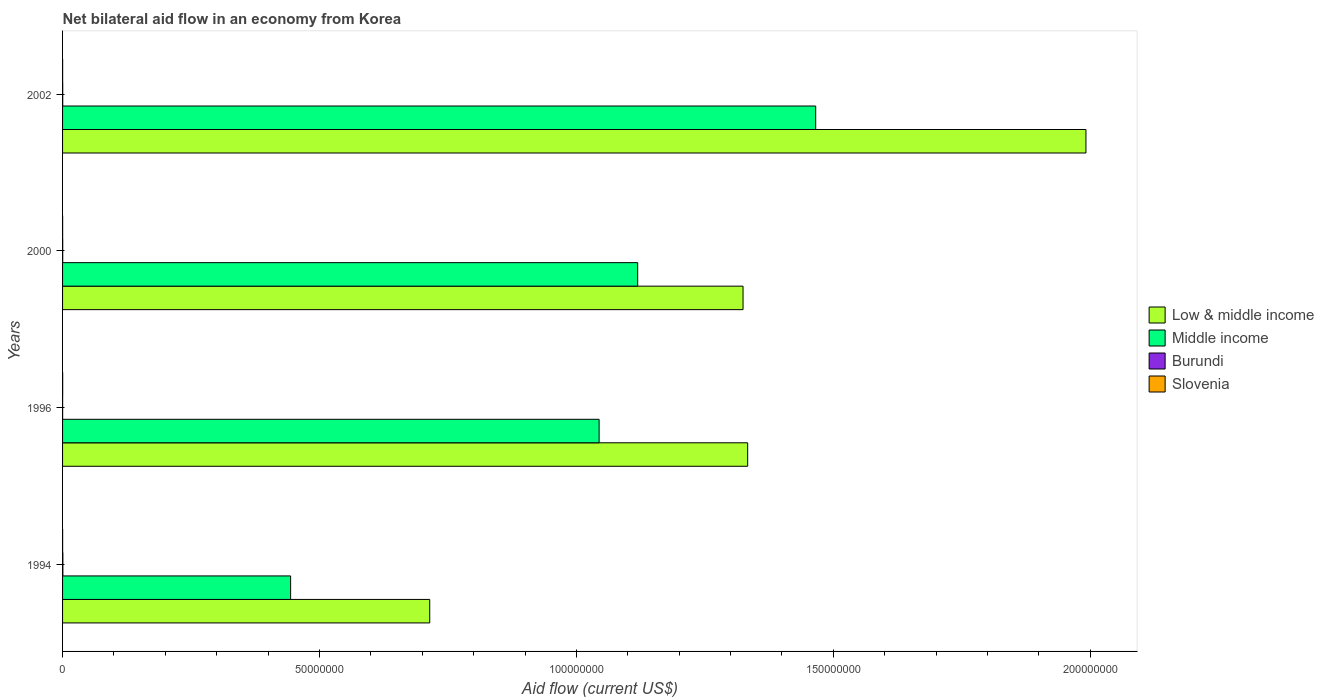How many different coloured bars are there?
Your answer should be very brief. 4. How many bars are there on the 1st tick from the bottom?
Provide a short and direct response. 4. What is the net bilateral aid flow in Low & middle income in 2000?
Offer a terse response. 1.32e+08. Across all years, what is the maximum net bilateral aid flow in Low & middle income?
Keep it short and to the point. 1.99e+08. Across all years, what is the minimum net bilateral aid flow in Burundi?
Offer a terse response. 10000. What is the difference between the net bilateral aid flow in Middle income in 2000 and that in 2002?
Offer a terse response. -3.46e+07. What is the difference between the net bilateral aid flow in Low & middle income in 1994 and the net bilateral aid flow in Burundi in 2002?
Your response must be concise. 7.14e+07. What is the average net bilateral aid flow in Low & middle income per year?
Keep it short and to the point. 1.34e+08. In the year 2002, what is the difference between the net bilateral aid flow in Low & middle income and net bilateral aid flow in Burundi?
Keep it short and to the point. 1.99e+08. Is the net bilateral aid flow in Low & middle income in 1996 less than that in 2000?
Make the answer very short. No. Is the difference between the net bilateral aid flow in Low & middle income in 1994 and 2002 greater than the difference between the net bilateral aid flow in Burundi in 1994 and 2002?
Make the answer very short. No. What is the difference between the highest and the second highest net bilateral aid flow in Middle income?
Provide a short and direct response. 3.46e+07. What is the difference between the highest and the lowest net bilateral aid flow in Low & middle income?
Your answer should be very brief. 1.28e+08. Is the sum of the net bilateral aid flow in Burundi in 1994 and 1996 greater than the maximum net bilateral aid flow in Low & middle income across all years?
Make the answer very short. No. What does the 2nd bar from the top in 1994 represents?
Keep it short and to the point. Burundi. How many years are there in the graph?
Your response must be concise. 4. What is the difference between two consecutive major ticks on the X-axis?
Ensure brevity in your answer.  5.00e+07. Are the values on the major ticks of X-axis written in scientific E-notation?
Offer a terse response. No. Does the graph contain grids?
Provide a short and direct response. No. How are the legend labels stacked?
Your answer should be very brief. Vertical. What is the title of the graph?
Offer a very short reply. Net bilateral aid flow in an economy from Korea. What is the Aid flow (current US$) in Low & middle income in 1994?
Ensure brevity in your answer.  7.14e+07. What is the Aid flow (current US$) in Middle income in 1994?
Provide a succinct answer. 4.44e+07. What is the Aid flow (current US$) in Burundi in 1994?
Ensure brevity in your answer.  6.00e+04. What is the Aid flow (current US$) in Slovenia in 1994?
Ensure brevity in your answer.  10000. What is the Aid flow (current US$) of Low & middle income in 1996?
Offer a very short reply. 1.33e+08. What is the Aid flow (current US$) of Middle income in 1996?
Offer a very short reply. 1.04e+08. What is the Aid flow (current US$) in Burundi in 1996?
Offer a very short reply. 10000. What is the Aid flow (current US$) of Slovenia in 1996?
Give a very brief answer. 2.00e+04. What is the Aid flow (current US$) in Low & middle income in 2000?
Make the answer very short. 1.32e+08. What is the Aid flow (current US$) of Middle income in 2000?
Provide a succinct answer. 1.12e+08. What is the Aid flow (current US$) in Burundi in 2000?
Your response must be concise. 3.00e+04. What is the Aid flow (current US$) in Slovenia in 2000?
Offer a terse response. 10000. What is the Aid flow (current US$) of Low & middle income in 2002?
Your answer should be compact. 1.99e+08. What is the Aid flow (current US$) of Middle income in 2002?
Provide a succinct answer. 1.47e+08. What is the Aid flow (current US$) of Burundi in 2002?
Make the answer very short. 3.00e+04. What is the Aid flow (current US$) of Slovenia in 2002?
Make the answer very short. 10000. Across all years, what is the maximum Aid flow (current US$) in Low & middle income?
Offer a very short reply. 1.99e+08. Across all years, what is the maximum Aid flow (current US$) in Middle income?
Offer a terse response. 1.47e+08. Across all years, what is the maximum Aid flow (current US$) of Burundi?
Offer a very short reply. 6.00e+04. Across all years, what is the maximum Aid flow (current US$) of Slovenia?
Make the answer very short. 2.00e+04. Across all years, what is the minimum Aid flow (current US$) of Low & middle income?
Your answer should be very brief. 7.14e+07. Across all years, what is the minimum Aid flow (current US$) in Middle income?
Offer a terse response. 4.44e+07. Across all years, what is the minimum Aid flow (current US$) in Burundi?
Your response must be concise. 10000. Across all years, what is the minimum Aid flow (current US$) in Slovenia?
Offer a terse response. 10000. What is the total Aid flow (current US$) in Low & middle income in the graph?
Give a very brief answer. 5.36e+08. What is the total Aid flow (current US$) of Middle income in the graph?
Your answer should be very brief. 4.07e+08. What is the difference between the Aid flow (current US$) of Low & middle income in 1994 and that in 1996?
Make the answer very short. -6.19e+07. What is the difference between the Aid flow (current US$) of Middle income in 1994 and that in 1996?
Offer a very short reply. -6.00e+07. What is the difference between the Aid flow (current US$) in Low & middle income in 1994 and that in 2000?
Make the answer very short. -6.10e+07. What is the difference between the Aid flow (current US$) in Middle income in 1994 and that in 2000?
Make the answer very short. -6.75e+07. What is the difference between the Aid flow (current US$) of Burundi in 1994 and that in 2000?
Offer a very short reply. 3.00e+04. What is the difference between the Aid flow (current US$) of Slovenia in 1994 and that in 2000?
Give a very brief answer. 0. What is the difference between the Aid flow (current US$) of Low & middle income in 1994 and that in 2002?
Your response must be concise. -1.28e+08. What is the difference between the Aid flow (current US$) of Middle income in 1994 and that in 2002?
Provide a short and direct response. -1.02e+08. What is the difference between the Aid flow (current US$) of Burundi in 1994 and that in 2002?
Ensure brevity in your answer.  3.00e+04. What is the difference between the Aid flow (current US$) of Slovenia in 1994 and that in 2002?
Keep it short and to the point. 0. What is the difference between the Aid flow (current US$) of Middle income in 1996 and that in 2000?
Give a very brief answer. -7.51e+06. What is the difference between the Aid flow (current US$) of Burundi in 1996 and that in 2000?
Provide a short and direct response. -2.00e+04. What is the difference between the Aid flow (current US$) in Low & middle income in 1996 and that in 2002?
Ensure brevity in your answer.  -6.58e+07. What is the difference between the Aid flow (current US$) of Middle income in 1996 and that in 2002?
Provide a succinct answer. -4.22e+07. What is the difference between the Aid flow (current US$) in Slovenia in 1996 and that in 2002?
Keep it short and to the point. 10000. What is the difference between the Aid flow (current US$) of Low & middle income in 2000 and that in 2002?
Make the answer very short. -6.67e+07. What is the difference between the Aid flow (current US$) of Middle income in 2000 and that in 2002?
Offer a very short reply. -3.46e+07. What is the difference between the Aid flow (current US$) in Burundi in 2000 and that in 2002?
Provide a short and direct response. 0. What is the difference between the Aid flow (current US$) in Slovenia in 2000 and that in 2002?
Keep it short and to the point. 0. What is the difference between the Aid flow (current US$) of Low & middle income in 1994 and the Aid flow (current US$) of Middle income in 1996?
Provide a succinct answer. -3.30e+07. What is the difference between the Aid flow (current US$) of Low & middle income in 1994 and the Aid flow (current US$) of Burundi in 1996?
Provide a succinct answer. 7.14e+07. What is the difference between the Aid flow (current US$) of Low & middle income in 1994 and the Aid flow (current US$) of Slovenia in 1996?
Offer a very short reply. 7.14e+07. What is the difference between the Aid flow (current US$) in Middle income in 1994 and the Aid flow (current US$) in Burundi in 1996?
Your answer should be very brief. 4.44e+07. What is the difference between the Aid flow (current US$) in Middle income in 1994 and the Aid flow (current US$) in Slovenia in 1996?
Your answer should be very brief. 4.44e+07. What is the difference between the Aid flow (current US$) in Low & middle income in 1994 and the Aid flow (current US$) in Middle income in 2000?
Your response must be concise. -4.05e+07. What is the difference between the Aid flow (current US$) in Low & middle income in 1994 and the Aid flow (current US$) in Burundi in 2000?
Provide a short and direct response. 7.14e+07. What is the difference between the Aid flow (current US$) of Low & middle income in 1994 and the Aid flow (current US$) of Slovenia in 2000?
Provide a succinct answer. 7.14e+07. What is the difference between the Aid flow (current US$) of Middle income in 1994 and the Aid flow (current US$) of Burundi in 2000?
Keep it short and to the point. 4.44e+07. What is the difference between the Aid flow (current US$) of Middle income in 1994 and the Aid flow (current US$) of Slovenia in 2000?
Your answer should be very brief. 4.44e+07. What is the difference between the Aid flow (current US$) in Burundi in 1994 and the Aid flow (current US$) in Slovenia in 2000?
Give a very brief answer. 5.00e+04. What is the difference between the Aid flow (current US$) in Low & middle income in 1994 and the Aid flow (current US$) in Middle income in 2002?
Ensure brevity in your answer.  -7.51e+07. What is the difference between the Aid flow (current US$) in Low & middle income in 1994 and the Aid flow (current US$) in Burundi in 2002?
Keep it short and to the point. 7.14e+07. What is the difference between the Aid flow (current US$) in Low & middle income in 1994 and the Aid flow (current US$) in Slovenia in 2002?
Your answer should be very brief. 7.14e+07. What is the difference between the Aid flow (current US$) of Middle income in 1994 and the Aid flow (current US$) of Burundi in 2002?
Provide a short and direct response. 4.44e+07. What is the difference between the Aid flow (current US$) of Middle income in 1994 and the Aid flow (current US$) of Slovenia in 2002?
Your answer should be compact. 4.44e+07. What is the difference between the Aid flow (current US$) of Burundi in 1994 and the Aid flow (current US$) of Slovenia in 2002?
Your answer should be compact. 5.00e+04. What is the difference between the Aid flow (current US$) in Low & middle income in 1996 and the Aid flow (current US$) in Middle income in 2000?
Your answer should be compact. 2.14e+07. What is the difference between the Aid flow (current US$) of Low & middle income in 1996 and the Aid flow (current US$) of Burundi in 2000?
Your response must be concise. 1.33e+08. What is the difference between the Aid flow (current US$) in Low & middle income in 1996 and the Aid flow (current US$) in Slovenia in 2000?
Provide a short and direct response. 1.33e+08. What is the difference between the Aid flow (current US$) in Middle income in 1996 and the Aid flow (current US$) in Burundi in 2000?
Your answer should be very brief. 1.04e+08. What is the difference between the Aid flow (current US$) of Middle income in 1996 and the Aid flow (current US$) of Slovenia in 2000?
Give a very brief answer. 1.04e+08. What is the difference between the Aid flow (current US$) of Burundi in 1996 and the Aid flow (current US$) of Slovenia in 2000?
Offer a terse response. 0. What is the difference between the Aid flow (current US$) of Low & middle income in 1996 and the Aid flow (current US$) of Middle income in 2002?
Make the answer very short. -1.32e+07. What is the difference between the Aid flow (current US$) of Low & middle income in 1996 and the Aid flow (current US$) of Burundi in 2002?
Your response must be concise. 1.33e+08. What is the difference between the Aid flow (current US$) in Low & middle income in 1996 and the Aid flow (current US$) in Slovenia in 2002?
Offer a very short reply. 1.33e+08. What is the difference between the Aid flow (current US$) in Middle income in 1996 and the Aid flow (current US$) in Burundi in 2002?
Ensure brevity in your answer.  1.04e+08. What is the difference between the Aid flow (current US$) of Middle income in 1996 and the Aid flow (current US$) of Slovenia in 2002?
Your response must be concise. 1.04e+08. What is the difference between the Aid flow (current US$) of Burundi in 1996 and the Aid flow (current US$) of Slovenia in 2002?
Keep it short and to the point. 0. What is the difference between the Aid flow (current US$) of Low & middle income in 2000 and the Aid flow (current US$) of Middle income in 2002?
Make the answer very short. -1.41e+07. What is the difference between the Aid flow (current US$) of Low & middle income in 2000 and the Aid flow (current US$) of Burundi in 2002?
Provide a succinct answer. 1.32e+08. What is the difference between the Aid flow (current US$) in Low & middle income in 2000 and the Aid flow (current US$) in Slovenia in 2002?
Your response must be concise. 1.32e+08. What is the difference between the Aid flow (current US$) of Middle income in 2000 and the Aid flow (current US$) of Burundi in 2002?
Offer a very short reply. 1.12e+08. What is the difference between the Aid flow (current US$) of Middle income in 2000 and the Aid flow (current US$) of Slovenia in 2002?
Offer a very short reply. 1.12e+08. What is the difference between the Aid flow (current US$) of Burundi in 2000 and the Aid flow (current US$) of Slovenia in 2002?
Offer a terse response. 2.00e+04. What is the average Aid flow (current US$) in Low & middle income per year?
Your answer should be very brief. 1.34e+08. What is the average Aid flow (current US$) in Middle income per year?
Provide a short and direct response. 1.02e+08. What is the average Aid flow (current US$) of Burundi per year?
Make the answer very short. 3.25e+04. What is the average Aid flow (current US$) in Slovenia per year?
Offer a very short reply. 1.25e+04. In the year 1994, what is the difference between the Aid flow (current US$) of Low & middle income and Aid flow (current US$) of Middle income?
Keep it short and to the point. 2.71e+07. In the year 1994, what is the difference between the Aid flow (current US$) of Low & middle income and Aid flow (current US$) of Burundi?
Make the answer very short. 7.14e+07. In the year 1994, what is the difference between the Aid flow (current US$) in Low & middle income and Aid flow (current US$) in Slovenia?
Provide a short and direct response. 7.14e+07. In the year 1994, what is the difference between the Aid flow (current US$) in Middle income and Aid flow (current US$) in Burundi?
Provide a succinct answer. 4.43e+07. In the year 1994, what is the difference between the Aid flow (current US$) in Middle income and Aid flow (current US$) in Slovenia?
Give a very brief answer. 4.44e+07. In the year 1996, what is the difference between the Aid flow (current US$) of Low & middle income and Aid flow (current US$) of Middle income?
Offer a very short reply. 2.89e+07. In the year 1996, what is the difference between the Aid flow (current US$) of Low & middle income and Aid flow (current US$) of Burundi?
Offer a very short reply. 1.33e+08. In the year 1996, what is the difference between the Aid flow (current US$) of Low & middle income and Aid flow (current US$) of Slovenia?
Your answer should be very brief. 1.33e+08. In the year 1996, what is the difference between the Aid flow (current US$) in Middle income and Aid flow (current US$) in Burundi?
Give a very brief answer. 1.04e+08. In the year 1996, what is the difference between the Aid flow (current US$) of Middle income and Aid flow (current US$) of Slovenia?
Your response must be concise. 1.04e+08. In the year 1996, what is the difference between the Aid flow (current US$) of Burundi and Aid flow (current US$) of Slovenia?
Your answer should be very brief. -10000. In the year 2000, what is the difference between the Aid flow (current US$) in Low & middle income and Aid flow (current US$) in Middle income?
Make the answer very short. 2.05e+07. In the year 2000, what is the difference between the Aid flow (current US$) in Low & middle income and Aid flow (current US$) in Burundi?
Provide a succinct answer. 1.32e+08. In the year 2000, what is the difference between the Aid flow (current US$) of Low & middle income and Aid flow (current US$) of Slovenia?
Give a very brief answer. 1.32e+08. In the year 2000, what is the difference between the Aid flow (current US$) in Middle income and Aid flow (current US$) in Burundi?
Your answer should be compact. 1.12e+08. In the year 2000, what is the difference between the Aid flow (current US$) of Middle income and Aid flow (current US$) of Slovenia?
Keep it short and to the point. 1.12e+08. In the year 2002, what is the difference between the Aid flow (current US$) of Low & middle income and Aid flow (current US$) of Middle income?
Your answer should be compact. 5.26e+07. In the year 2002, what is the difference between the Aid flow (current US$) of Low & middle income and Aid flow (current US$) of Burundi?
Your answer should be compact. 1.99e+08. In the year 2002, what is the difference between the Aid flow (current US$) of Low & middle income and Aid flow (current US$) of Slovenia?
Keep it short and to the point. 1.99e+08. In the year 2002, what is the difference between the Aid flow (current US$) in Middle income and Aid flow (current US$) in Burundi?
Offer a terse response. 1.47e+08. In the year 2002, what is the difference between the Aid flow (current US$) in Middle income and Aid flow (current US$) in Slovenia?
Make the answer very short. 1.47e+08. In the year 2002, what is the difference between the Aid flow (current US$) in Burundi and Aid flow (current US$) in Slovenia?
Give a very brief answer. 2.00e+04. What is the ratio of the Aid flow (current US$) in Low & middle income in 1994 to that in 1996?
Your answer should be very brief. 0.54. What is the ratio of the Aid flow (current US$) of Middle income in 1994 to that in 1996?
Offer a terse response. 0.43. What is the ratio of the Aid flow (current US$) in Slovenia in 1994 to that in 1996?
Ensure brevity in your answer.  0.5. What is the ratio of the Aid flow (current US$) in Low & middle income in 1994 to that in 2000?
Your response must be concise. 0.54. What is the ratio of the Aid flow (current US$) of Middle income in 1994 to that in 2000?
Your answer should be compact. 0.4. What is the ratio of the Aid flow (current US$) of Low & middle income in 1994 to that in 2002?
Your answer should be compact. 0.36. What is the ratio of the Aid flow (current US$) of Middle income in 1994 to that in 2002?
Offer a terse response. 0.3. What is the ratio of the Aid flow (current US$) in Burundi in 1994 to that in 2002?
Ensure brevity in your answer.  2. What is the ratio of the Aid flow (current US$) in Low & middle income in 1996 to that in 2000?
Keep it short and to the point. 1.01. What is the ratio of the Aid flow (current US$) in Middle income in 1996 to that in 2000?
Your response must be concise. 0.93. What is the ratio of the Aid flow (current US$) of Burundi in 1996 to that in 2000?
Offer a terse response. 0.33. What is the ratio of the Aid flow (current US$) in Slovenia in 1996 to that in 2000?
Your response must be concise. 2. What is the ratio of the Aid flow (current US$) of Low & middle income in 1996 to that in 2002?
Your response must be concise. 0.67. What is the ratio of the Aid flow (current US$) of Middle income in 1996 to that in 2002?
Provide a short and direct response. 0.71. What is the ratio of the Aid flow (current US$) of Slovenia in 1996 to that in 2002?
Give a very brief answer. 2. What is the ratio of the Aid flow (current US$) in Low & middle income in 2000 to that in 2002?
Your response must be concise. 0.66. What is the ratio of the Aid flow (current US$) of Middle income in 2000 to that in 2002?
Provide a short and direct response. 0.76. What is the ratio of the Aid flow (current US$) of Burundi in 2000 to that in 2002?
Your response must be concise. 1. What is the difference between the highest and the second highest Aid flow (current US$) of Low & middle income?
Make the answer very short. 6.58e+07. What is the difference between the highest and the second highest Aid flow (current US$) in Middle income?
Your response must be concise. 3.46e+07. What is the difference between the highest and the second highest Aid flow (current US$) of Burundi?
Provide a succinct answer. 3.00e+04. What is the difference between the highest and the lowest Aid flow (current US$) in Low & middle income?
Offer a terse response. 1.28e+08. What is the difference between the highest and the lowest Aid flow (current US$) in Middle income?
Offer a very short reply. 1.02e+08. What is the difference between the highest and the lowest Aid flow (current US$) of Slovenia?
Make the answer very short. 10000. 